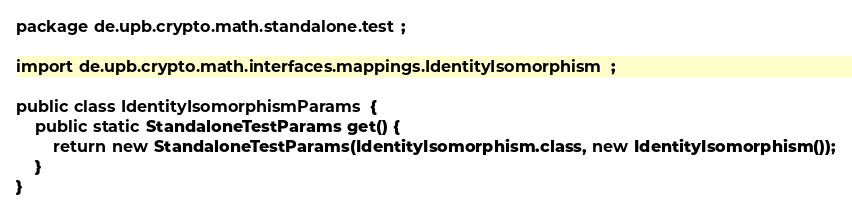Convert code to text. <code><loc_0><loc_0><loc_500><loc_500><_Java_>package de.upb.crypto.math.standalone.test;

import de.upb.crypto.math.interfaces.mappings.IdentityIsomorphism;

public class IdentityIsomorphismParams {
    public static StandaloneTestParams get() {
        return new StandaloneTestParams(IdentityIsomorphism.class, new IdentityIsomorphism());
    }
}
</code> 